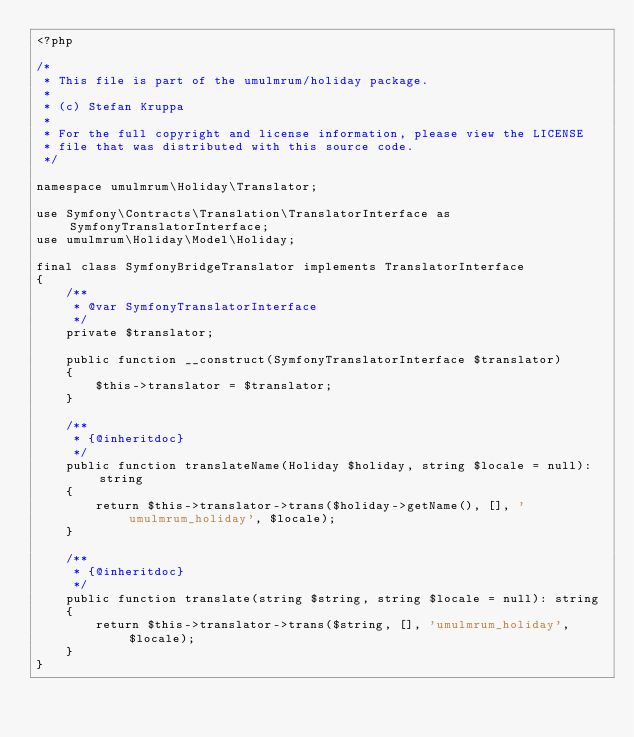Convert code to text. <code><loc_0><loc_0><loc_500><loc_500><_PHP_><?php

/*
 * This file is part of the umulmrum/holiday package.
 *
 * (c) Stefan Kruppa
 *
 * For the full copyright and license information, please view the LICENSE
 * file that was distributed with this source code.
 */

namespace umulmrum\Holiday\Translator;

use Symfony\Contracts\Translation\TranslatorInterface as SymfonyTranslatorInterface;
use umulmrum\Holiday\Model\Holiday;

final class SymfonyBridgeTranslator implements TranslatorInterface
{
    /**
     * @var SymfonyTranslatorInterface
     */
    private $translator;

    public function __construct(SymfonyTranslatorInterface $translator)
    {
        $this->translator = $translator;
    }

    /**
     * {@inheritdoc}
     */
    public function translateName(Holiday $holiday, string $locale = null): string
    {
        return $this->translator->trans($holiday->getName(), [], 'umulmrum_holiday', $locale);
    }

    /**
     * {@inheritdoc}
     */
    public function translate(string $string, string $locale = null): string
    {
        return $this->translator->trans($string, [], 'umulmrum_holiday', $locale);
    }
}
</code> 